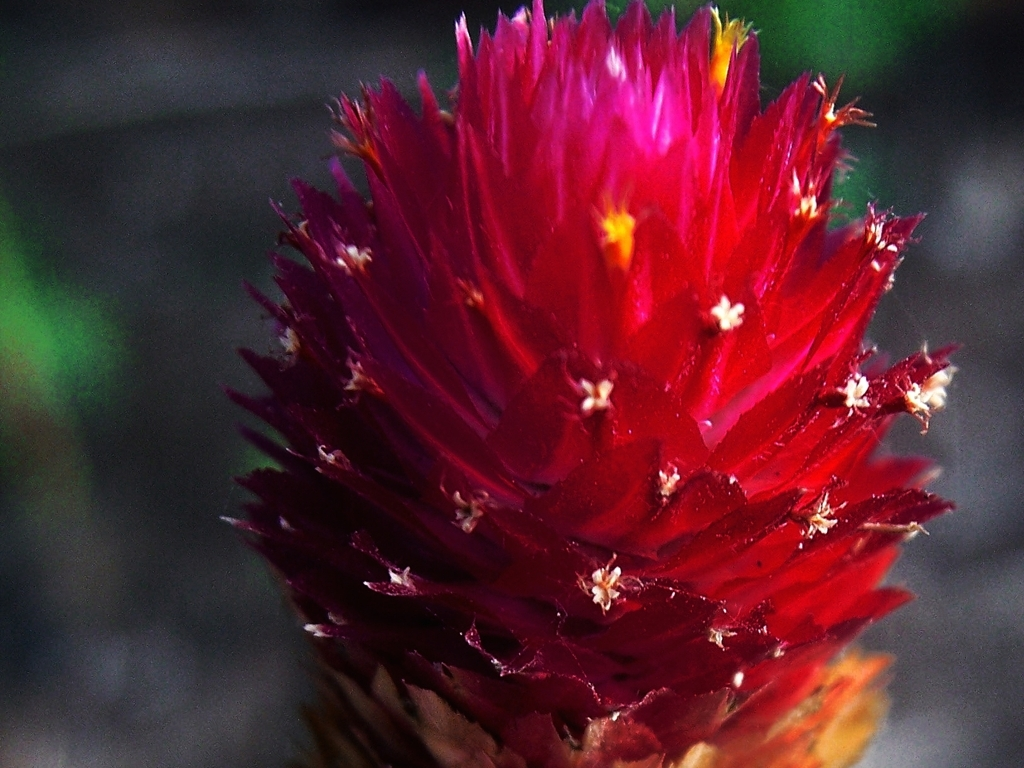What is the color quality like in the image?
A. Dull
B. Lack of color
C. Rich
D. Faded The color quality in the image can be described as rich, exhibiting deep and vibrant hues, especially the vivid red of the flower, which stands out with great intensity and clarity against the contrasting background. 